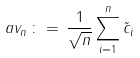Convert formula to latex. <formula><loc_0><loc_0><loc_500><loc_500>a v _ { n } \, \colon = \, \frac { 1 } { \sqrt { n } } \sum _ { i = 1 } ^ { n } \tilde { c } _ { i }</formula> 